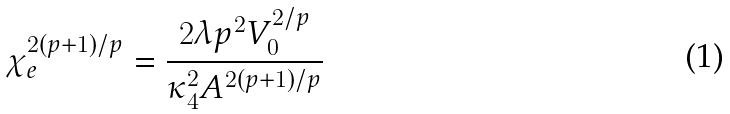<formula> <loc_0><loc_0><loc_500><loc_500>\chi _ { e } ^ { 2 ( p + 1 ) / p } = \frac { 2 \lambda p ^ { 2 } V _ { 0 } ^ { 2 / p } } { \kappa _ { 4 } ^ { 2 } A ^ { 2 ( p + 1 ) / p } }</formula> 